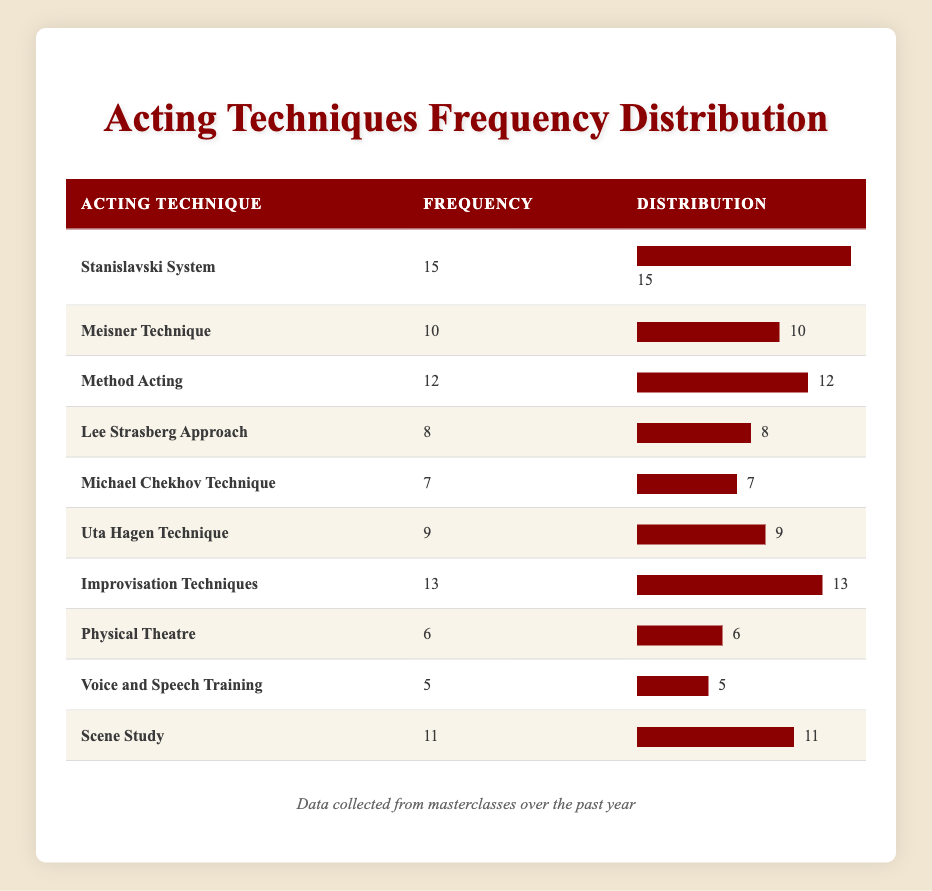What is the frequency of the Stanislavski System technique? The frequency of the Stanislavski System technique is listed directly in the table under the "Frequency" column, which shows a value of 15.
Answer: 15 Which technique has the lowest frequency? The table lists all techniques with their corresponding frequencies. The lowest frequency is found under the "Physical Theatre" technique with a frequency of 6.
Answer: 6 What is the total frequency of all acting techniques taught? To find the total frequency, sum all the frequencies from the frequency column: 15 + 10 + 12 + 8 + 7 + 9 + 13 + 6 + 5 + 11 = 96. This gives a total frequency of 96 for all acting techniques.
Answer: 96 Is the frequency of the Meisner Technique greater than that of the Michael Chekhov Technique? The frequency for the Meisner Technique is 10 and the frequency for the Michael Chekhov Technique is 7. Since 10 is greater than 7, the answer is yes.
Answer: Yes What is the average frequency of the techniques listed? First, we calculate the total frequency, which is 96. Then, divide this number by the number of techniques, which is 10: 96 / 10 = 9.6. The average frequency of the techniques taught is 9.6.
Answer: 9.6 How many techniques have a frequency greater than 10? From the table, we count the techniques with frequencies greater than 10. They are: Stanislavski System (15), Method Acting (12), Improvisation Techniques (13), and Scene Study (11). This totals to 4 techniques with a frequency greater than 10.
Answer: 4 Which technique is taught most frequently, and by how much does it exceed the second most frequent technique? The most frequently taught technique is the Stanislavski System with a frequency of 15. The second most frequent technique is the Improvisation Techniques with a frequency of 13. The difference between them is 15 - 13 = 2.
Answer: 2 Does the Uta Hagen Technique have a higher frequency than Voice and Speech Training? The Uta Hagen Technique has a frequency of 9, while the Voice and Speech Training has a frequency of 5. Since 9 is higher than 5, the answer is yes.
Answer: Yes How does the frequency of Scene Study compare to Physical Theatre? The frequency of Scene Study is 11, while for Physical Theatre it is 6. To compare, we see that 11 is greater than 6, so Scene Study is taught more frequently than Physical Theatre.
Answer: Scene Study is greater 